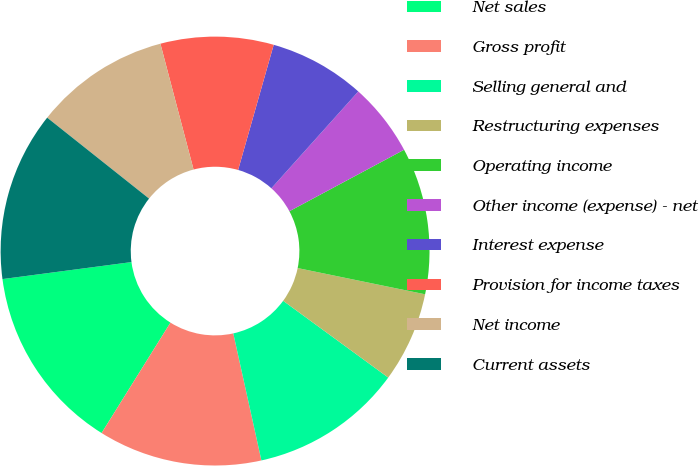Convert chart. <chart><loc_0><loc_0><loc_500><loc_500><pie_chart><fcel>Net sales<fcel>Gross profit<fcel>Selling general and<fcel>Restructuring expenses<fcel>Operating income<fcel>Other income (expense) - net<fcel>Interest expense<fcel>Provision for income taxes<fcel>Net income<fcel>Current assets<nl><fcel>14.04%<fcel>12.34%<fcel>11.49%<fcel>6.81%<fcel>11.06%<fcel>5.53%<fcel>7.23%<fcel>8.51%<fcel>10.21%<fcel>12.77%<nl></chart> 